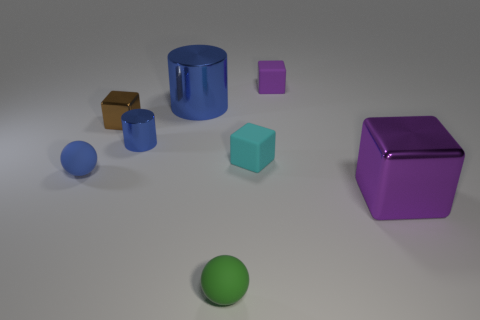Subtract all purple shiny cubes. How many cubes are left? 3 Subtract all blue cylinders. How many purple cubes are left? 2 Add 1 tiny balls. How many objects exist? 9 Subtract all purple cubes. How many cubes are left? 2 Subtract 2 cylinders. How many cylinders are left? 0 Add 7 small blue metal cylinders. How many small blue metal cylinders exist? 8 Subtract 0 yellow cylinders. How many objects are left? 8 Subtract all spheres. How many objects are left? 6 Subtract all yellow blocks. Subtract all blue cylinders. How many blocks are left? 4 Subtract all brown blocks. Subtract all tiny green spheres. How many objects are left? 6 